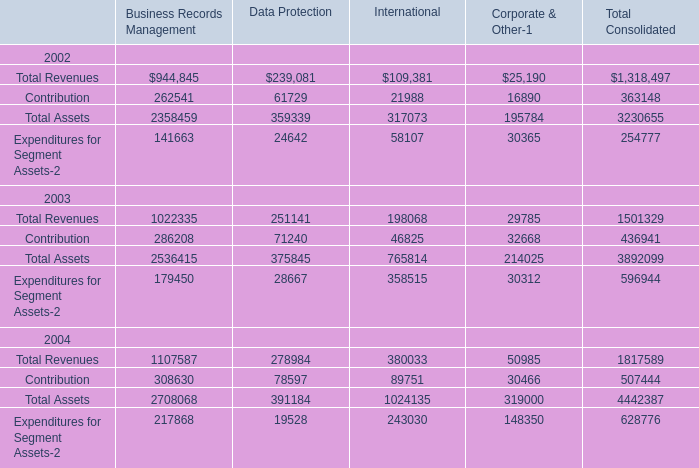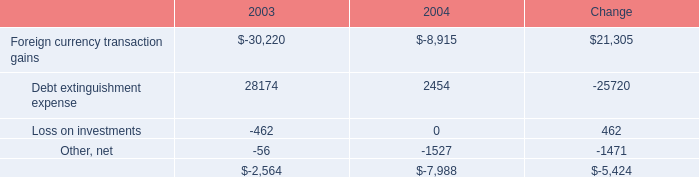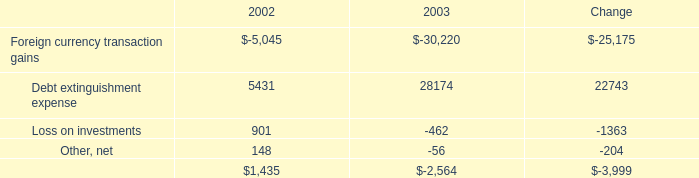What's the average of Debt extinguishment expense of 2003, and Contribution 2004 of International ? 
Computations: ((28174.0 + 89751.0) / 2)
Answer: 58962.5. 